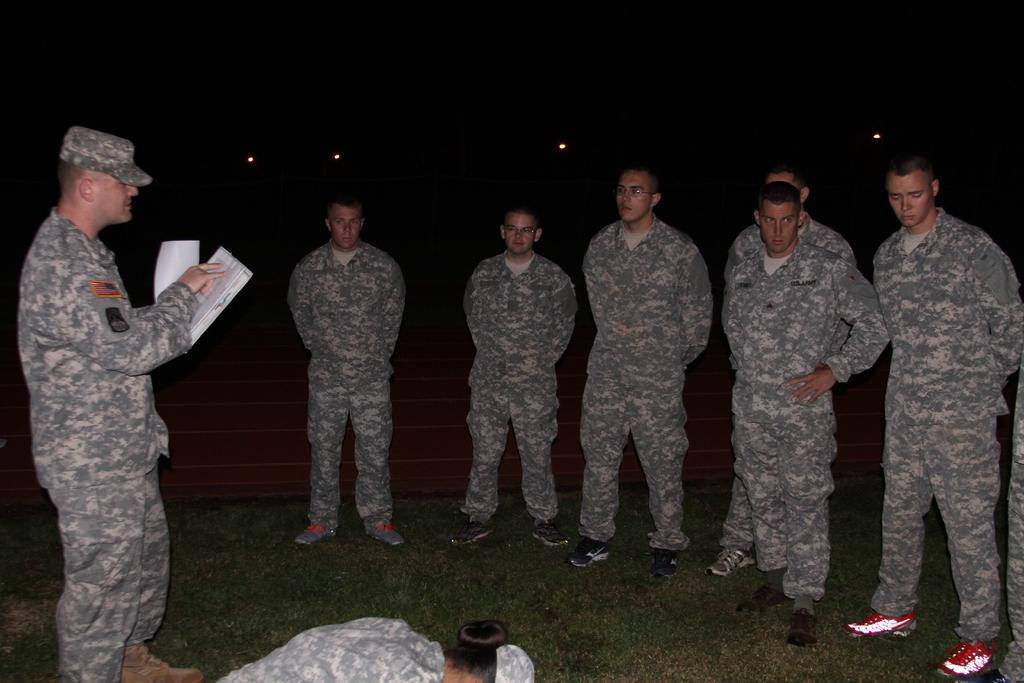How many people are in the image? There is a group of people standing in the image. What is one person in the group holding? There is a person holding papers in the image. What can be seen illuminating the scene in the image? There are lights visible in the image. What is the color of the background in the image? The background of the image is dark. What type of print can be seen on the person's shirt in the image? There is no information about the person's shirt in the provided facts, so we cannot determine if there is a print on it. 